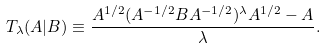Convert formula to latex. <formula><loc_0><loc_0><loc_500><loc_500>T _ { \lambda } ( A | B ) \equiv \frac { A ^ { 1 / 2 } ( A ^ { - 1 / 2 } B A ^ { - 1 / 2 } ) ^ { \lambda } A ^ { 1 / 2 } - A } { \lambda } .</formula> 